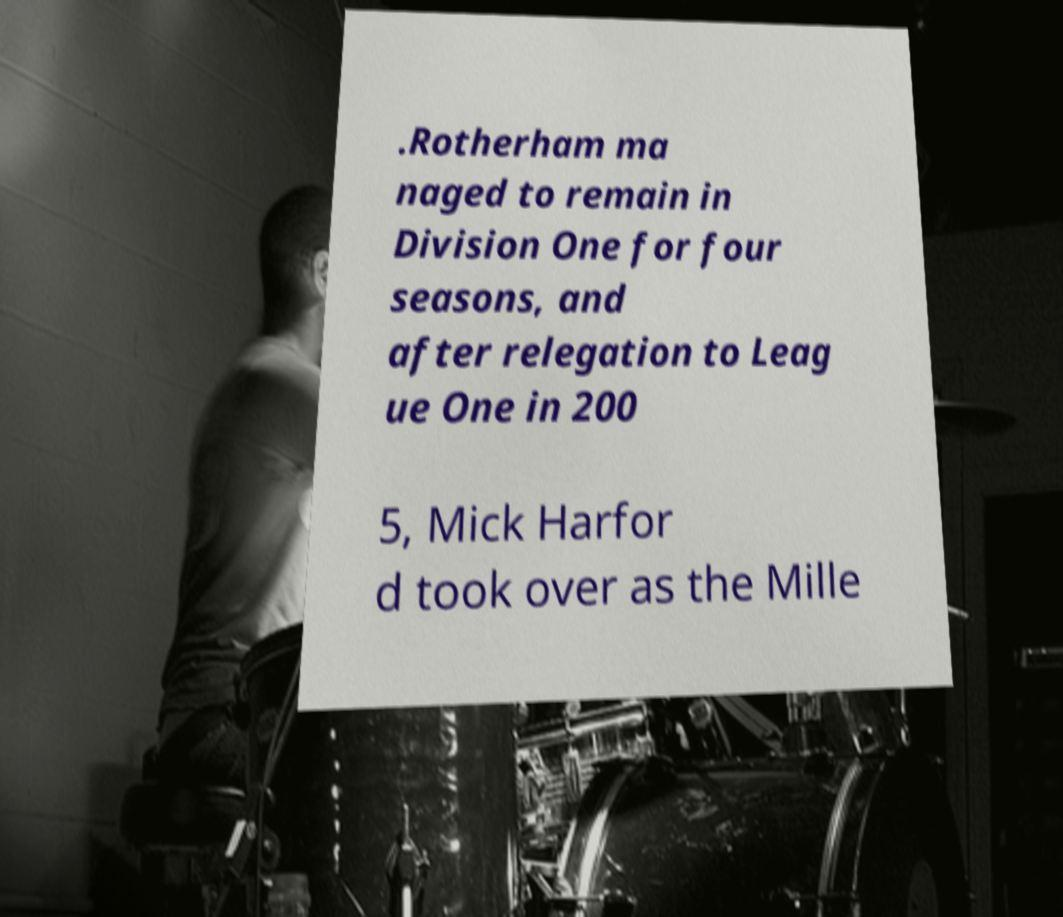Can you accurately transcribe the text from the provided image for me? .Rotherham ma naged to remain in Division One for four seasons, and after relegation to Leag ue One in 200 5, Mick Harfor d took over as the Mille 